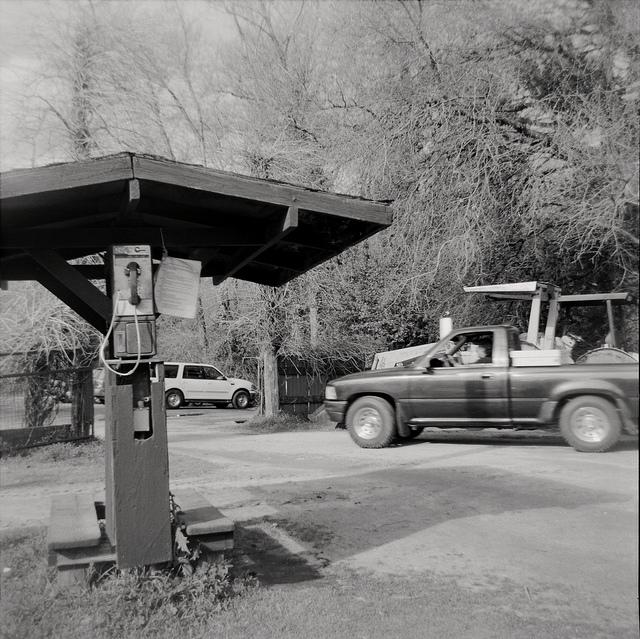The item under the roof can best be described as what? payphone 